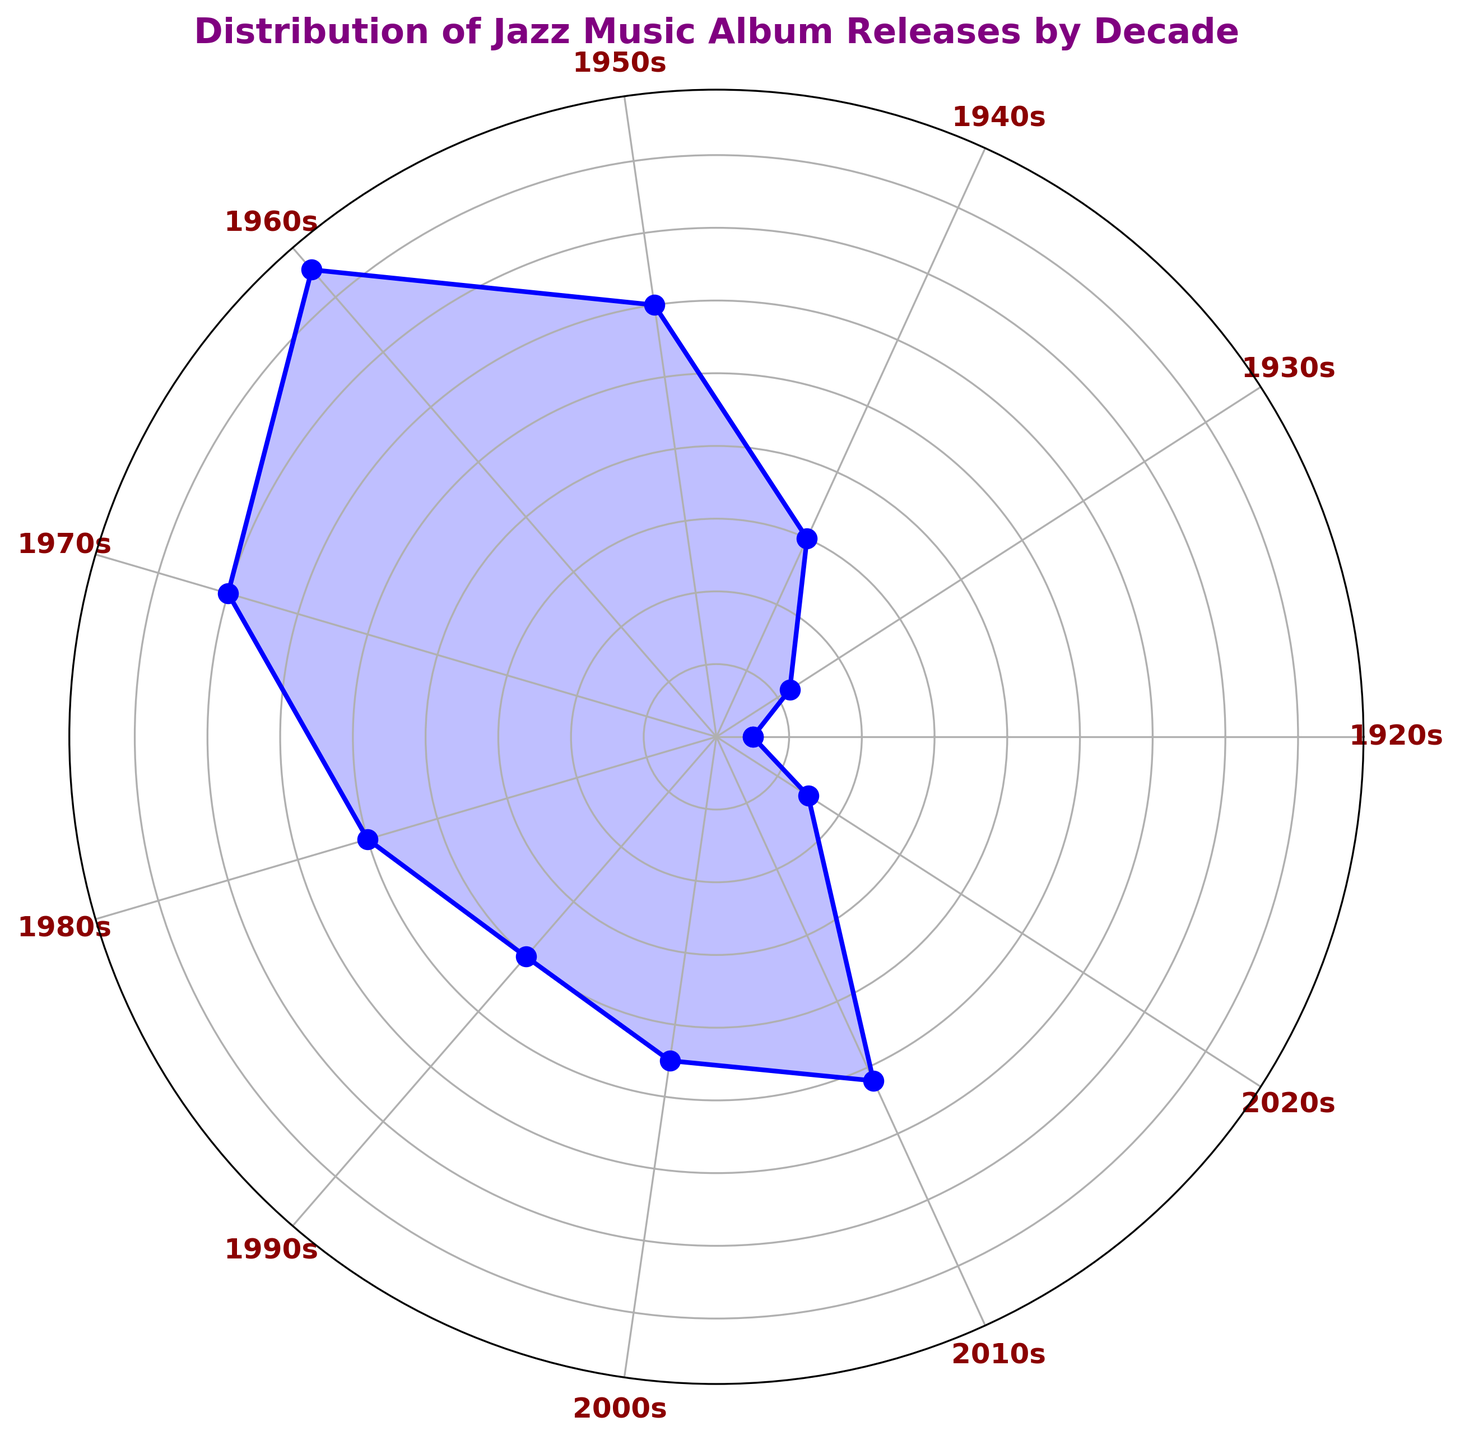Which decade had the highest number of jazz album releases? The 1960s bar reaches the highest point in the chart, indicating that this decade had the most releases.
Answer: 1960s Compare the number of album releases between the 1940s and the 1980s. Which decade had more releases? The length of the bar for the 1940s is shorter than the 1980s, indicating the 1980s had more releases.
Answer: 1980s Is the number of album releases in the 2000s higher or lower than in the 1990s? The bar for the 2000s is taller than the bar for the 1990s, so the 2000s had more album releases.
Answer: Higher What's the difference in album releases between the 1950s and 1970s? The 1950s bar shows 600 releases, and the 1970s bar shows 700 releases. The difference is 700 - 600.
Answer: 100 Which decade marks a significant drop in the number of jazz album releases compared to the previous decade? Observing the bars, there is a noticeable drop from the 1960s to the 1970s.
Answer: 1970s Compare the total album releases before 1950 to those after 1950. Which period had more releases? Summing the releases for 1920s to 1940s gives 50 + 120 + 300 = 470. Summing from 1950s onwards gives 600 + 850 + 700 + 500 + 400 + 450 + 520 + 150 = 4170.
Answer: After 1950 What is the total number of jazz album releases from the 1980s to the 2010s? Summing the releases from 1980s to 2010s: 500 + 400 + 450 + 520 = 1870.
Answer: 1870 Which decades had fewer than 200 album releases? The bars for 1920s and 2020s are the shortest and correspond to fewer than 200 releases.
Answer: 1920s, 2020s 